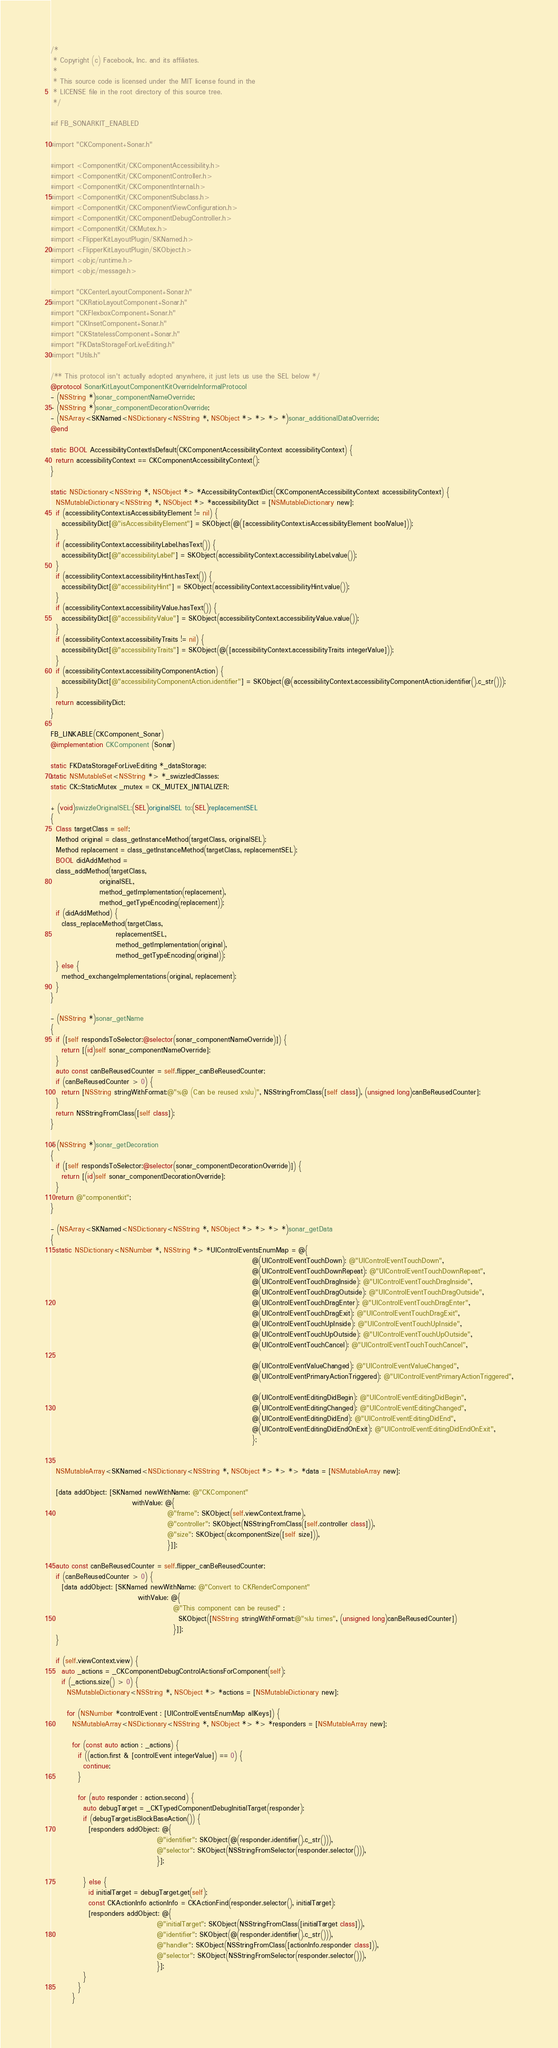<code> <loc_0><loc_0><loc_500><loc_500><_ObjectiveC_>/*
 * Copyright (c) Facebook, Inc. and its affiliates.
 *
 * This source code is licensed under the MIT license found in the
 * LICENSE file in the root directory of this source tree.
 */

#if FB_SONARKIT_ENABLED

#import "CKComponent+Sonar.h"

#import <ComponentKit/CKComponentAccessibility.h>
#import <ComponentKit/CKComponentController.h>
#import <ComponentKit/CKComponentInternal.h>
#import <ComponentKit/CKComponentSubclass.h>
#import <ComponentKit/CKComponentViewConfiguration.h>
#import <ComponentKit/CKComponentDebugController.h>
#import <ComponentKit/CKMutex.h>
#import <FlipperKitLayoutPlugin/SKNamed.h>
#import <FlipperKitLayoutPlugin/SKObject.h>
#import <objc/runtime.h>
#import <objc/message.h>

#import "CKCenterLayoutComponent+Sonar.h"
#import "CKRatioLayoutComponent+Sonar.h"
#import "CKFlexboxComponent+Sonar.h"
#import "CKInsetComponent+Sonar.h"
#import "CKStatelessComponent+Sonar.h"
#import "FKDataStorageForLiveEditing.h"
#import "Utils.h"

/** This protocol isn't actually adopted anywhere, it just lets us use the SEL below */
@protocol SonarKitLayoutComponentKitOverrideInformalProtocol
- (NSString *)sonar_componentNameOverride;
- (NSString *)sonar_componentDecorationOverride;
- (NSArray<SKNamed<NSDictionary<NSString *, NSObject *> *> *> *)sonar_additionalDataOverride;
@end

static BOOL AccessibilityContextIsDefault(CKComponentAccessibilityContext accessibilityContext) {
  return accessibilityContext == CKComponentAccessibilityContext();
}

static NSDictionary<NSString *, NSObject *> *AccessibilityContextDict(CKComponentAccessibilityContext accessibilityContext) {
  NSMutableDictionary<NSString *, NSObject *> *accessibilityDict = [NSMutableDictionary new];
  if (accessibilityContext.isAccessibilityElement != nil) {
    accessibilityDict[@"isAccessibilityElement"] = SKObject(@([accessibilityContext.isAccessibilityElement boolValue]));
  }
  if (accessibilityContext.accessibilityLabel.hasText()) {
    accessibilityDict[@"accessibilityLabel"] = SKObject(accessibilityContext.accessibilityLabel.value());
  }
  if (accessibilityContext.accessibilityHint.hasText()) {
    accessibilityDict[@"accessibilityHint"] = SKObject(accessibilityContext.accessibilityHint.value());
  }
  if (accessibilityContext.accessibilityValue.hasText()) {
    accessibilityDict[@"accessibilityValue"] = SKObject(accessibilityContext.accessibilityValue.value());
  }
  if (accessibilityContext.accessibilityTraits != nil) {
    accessibilityDict[@"accessibilityTraits"] = SKObject(@([accessibilityContext.accessibilityTraits integerValue]));
  }
  if (accessibilityContext.accessibilityComponentAction) {
    accessibilityDict[@"accessibilityComponentAction.identifier"] = SKObject(@(accessibilityContext.accessibilityComponentAction.identifier().c_str()));
  }
  return accessibilityDict;
}

FB_LINKABLE(CKComponent_Sonar)
@implementation CKComponent (Sonar)

static FKDataStorageForLiveEditing *_dataStorage;
static NSMutableSet<NSString *> *_swizzledClasses;
static CK::StaticMutex _mutex = CK_MUTEX_INITIALIZER;

+ (void)swizzleOriginalSEL:(SEL)originalSEL to:(SEL)replacementSEL
{
  Class targetClass = self;
  Method original = class_getInstanceMethod(targetClass, originalSEL);
  Method replacement = class_getInstanceMethod(targetClass, replacementSEL);
  BOOL didAddMethod =
  class_addMethod(targetClass,
                  originalSEL,
                  method_getImplementation(replacement),
                  method_getTypeEncoding(replacement));
  if (didAddMethod) {
    class_replaceMethod(targetClass,
                        replacementSEL,
                        method_getImplementation(original),
                        method_getTypeEncoding(original));
  } else {
    method_exchangeImplementations(original, replacement);
  }
}

- (NSString *)sonar_getName
{
  if ([self respondsToSelector:@selector(sonar_componentNameOverride)]) {
    return [(id)self sonar_componentNameOverride];
  }
  auto const canBeReusedCounter = self.flipper_canBeReusedCounter;
  if (canBeReusedCounter > 0) {
    return [NSString stringWithFormat:@"%@ (Can be reused x%lu)", NSStringFromClass([self class]), (unsigned long)canBeReusedCounter];
  }
  return NSStringFromClass([self class]);
}

- (NSString *)sonar_getDecoration
{
  if ([self respondsToSelector:@selector(sonar_componentDecorationOverride)]) {
    return [(id)self sonar_componentDecorationOverride];
  }
  return @"componentkit";
}

- (NSArray<SKNamed<NSDictionary<NSString *, NSObject *> *> *> *)sonar_getData
{
  static NSDictionary<NSNumber *, NSString *> *UIControlEventsEnumMap = @{
                                                                          @(UIControlEventTouchDown): @"UIControlEventTouchDown",
                                                                          @(UIControlEventTouchDownRepeat): @"UIControlEventTouchDownRepeat",
                                                                          @(UIControlEventTouchDragInside): @"UIControlEventTouchDragInside",
                                                                          @(UIControlEventTouchDragOutside): @"UIControlEventTouchDragOutside",
                                                                          @(UIControlEventTouchDragEnter): @"UIControlEventTouchDragEnter",
                                                                          @(UIControlEventTouchDragExit): @"UIControlEventTouchDragExit",
                                                                          @(UIControlEventTouchUpInside): @"UIControlEventTouchUpInside",
                                                                          @(UIControlEventTouchUpOutside): @"UIControlEventTouchUpOutside",
                                                                          @(UIControlEventTouchCancel): @"UIControlEventTouchTouchCancel",

                                                                          @(UIControlEventValueChanged): @"UIControlEventValueChanged",
                                                                          @(UIControlEventPrimaryActionTriggered): @"UIControlEventPrimaryActionTriggered",

                                                                          @(UIControlEventEditingDidBegin): @"UIControlEventEditingDidBegin",
                                                                          @(UIControlEventEditingChanged): @"UIControlEventEditingChanged",
                                                                          @(UIControlEventEditingDidEnd): @"UIControlEventEditingDidEnd",
                                                                          @(UIControlEventEditingDidEndOnExit): @"UIControlEventEditingDidEndOnExit",
                                                                          };


  NSMutableArray<SKNamed<NSDictionary<NSString *, NSObject *> *> *> *data = [NSMutableArray new];

  [data addObject: [SKNamed newWithName: @"CKComponent"
                              withValue: @{
                                           @"frame": SKObject(self.viewContext.frame),
                                           @"controller": SKObject(NSStringFromClass([self.controller class])),
                                           @"size": SKObject(ckcomponentSize([self size])),
                                           }]];

  auto const canBeReusedCounter = self.flipper_canBeReusedCounter;
  if (canBeReusedCounter > 0) {
    [data addObject: [SKNamed newWithName: @"Convert to CKRenderComponent"
                                withValue: @{
                                             @"This component can be reused" :
                                               SKObject([NSString stringWithFormat:@"%lu times", (unsigned long)canBeReusedCounter])
                                             }]];
  }

  if (self.viewContext.view) {
    auto _actions = _CKComponentDebugControlActionsForComponent(self);
    if (_actions.size() > 0) {
      NSMutableDictionary<NSString *, NSObject *> *actions = [NSMutableDictionary new];

      for (NSNumber *controlEvent : [UIControlEventsEnumMap allKeys]) {
        NSMutableArray<NSDictionary<NSString *, NSObject *> *> *responders = [NSMutableArray new];

        for (const auto action : _actions) {
          if ((action.first & [controlEvent integerValue]) == 0) {
            continue;
          }

          for (auto responder : action.second) {
            auto debugTarget = _CKTypedComponentDebugInitialTarget(responder);
            if (debugTarget.isBlockBaseAction()) {
              [responders addObject: @{
                                       @"identifier": SKObject(@(responder.identifier().c_str())),
                                       @"selector": SKObject(NSStringFromSelector(responder.selector())),
                                       }];

            } else {
              id initialTarget = debugTarget.get(self);
              const CKActionInfo actionInfo = CKActionFind(responder.selector(), initialTarget);
              [responders addObject: @{
                                       @"initialTarget": SKObject(NSStringFromClass([initialTarget class])),
                                       @"identifier": SKObject(@(responder.identifier().c_str())),
                                       @"handler": SKObject(NSStringFromClass([actionInfo.responder class])),
                                       @"selector": SKObject(NSStringFromSelector(responder.selector())),
                                       }];
            }
          }
        }
</code> 